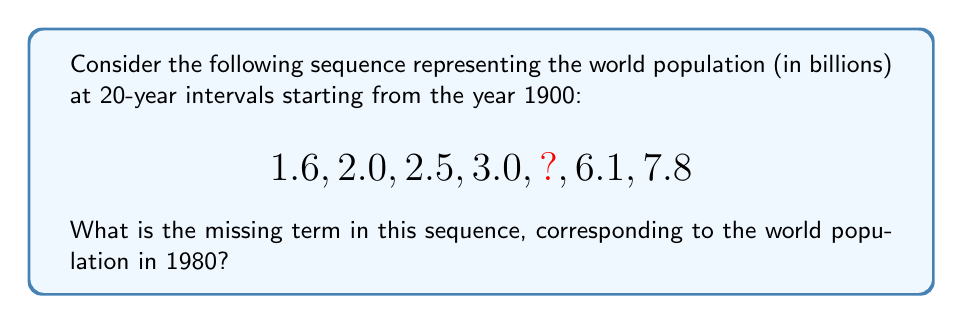Solve this math problem. To find the missing term, let's analyze the pattern in the given sequence:

1. First, we need to understand what each term represents:
   1900: 1.6 billion
   1920: 2.0 billion
   1940: 2.5 billion
   1960: 3.0 billion
   1980: ? (missing term)
   2000: 6.1 billion
   2020: 7.8 billion

2. We can observe that the population growth is not linear. It shows an accelerating growth pattern, which is typical for human population growth in the 20th century.

3. To estimate the missing term, we can calculate the growth rate between each interval:

   1900-1920: $\frac{2.0 - 1.6}{1.6} = 25\%$ growth
   1920-1940: $\frac{2.5 - 2.0}{2.0} = 25\%$ growth
   1940-1960: $\frac{3.0 - 2.5}{2.5} = 20\%$ growth
   1960-1980: Unknown
   1980-2000: $\frac{6.1 - x}{x}$, where x is the missing term
   2000-2020: $\frac{7.8 - 6.1}{6.1} \approx 27.9\%$ growth

4. We can see that the growth rate increased significantly between 1980 and 2000. A reasonable estimate for the 1980 population would be around 4.5 billion, as this would represent an accelerating growth pattern:

   1960-1980: $\frac{4.5 - 3.0}{3.0} = 50\%$ growth
   1980-2000: $\frac{6.1 - 4.5}{4.5} \approx 35.6\%$ growth

5. This estimate of 4.5 billion for 1980 aligns with historical data and reflects the accelerating population growth observed in the latter half of the 20th century.
Answer: 4.5 